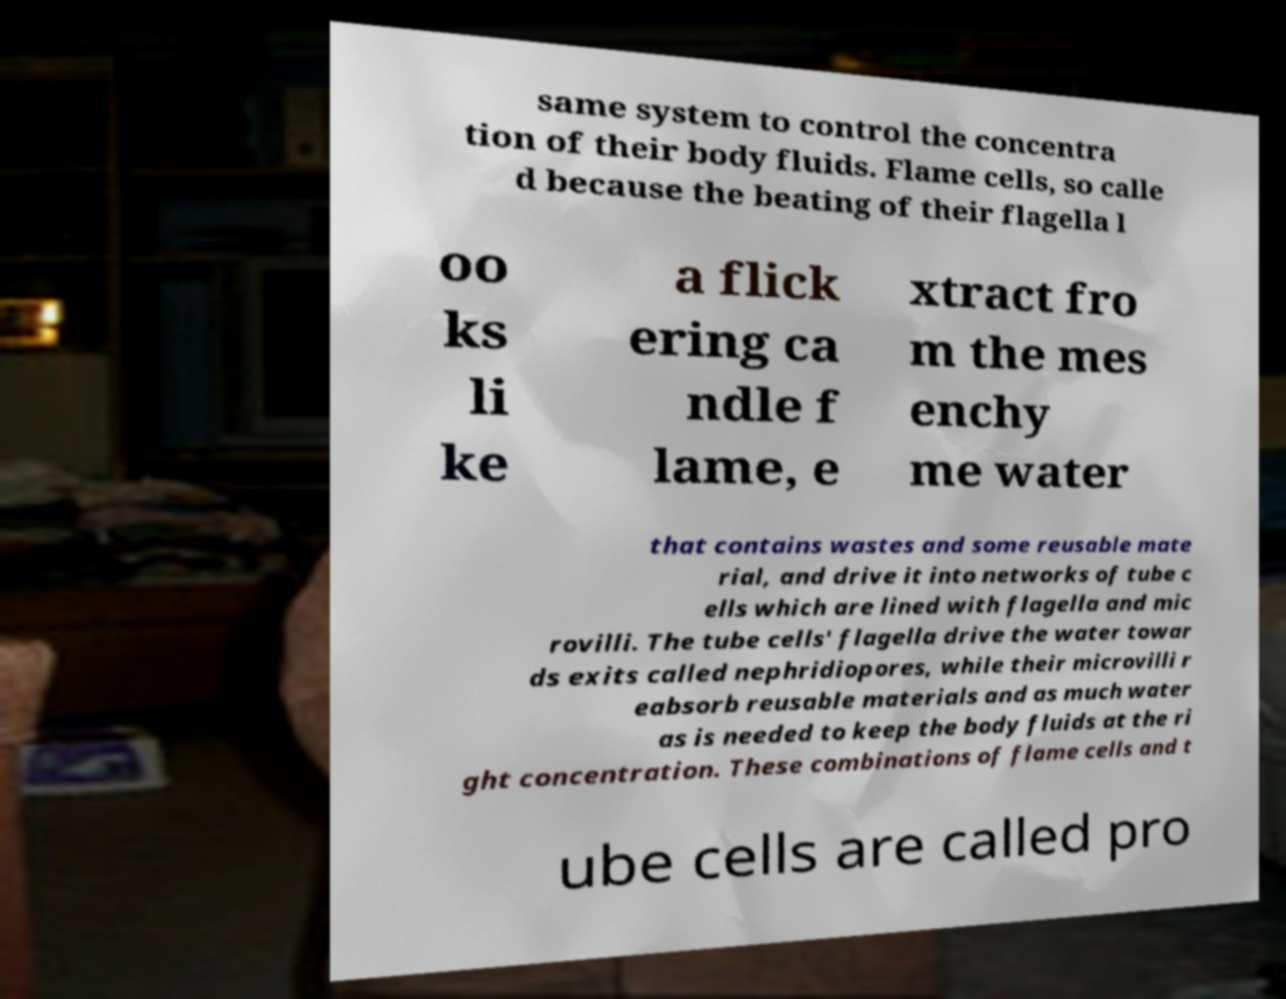Could you extract and type out the text from this image? same system to control the concentra tion of their body fluids. Flame cells, so calle d because the beating of their flagella l oo ks li ke a flick ering ca ndle f lame, e xtract fro m the mes enchy me water that contains wastes and some reusable mate rial, and drive it into networks of tube c ells which are lined with flagella and mic rovilli. The tube cells' flagella drive the water towar ds exits called nephridiopores, while their microvilli r eabsorb reusable materials and as much water as is needed to keep the body fluids at the ri ght concentration. These combinations of flame cells and t ube cells are called pro 